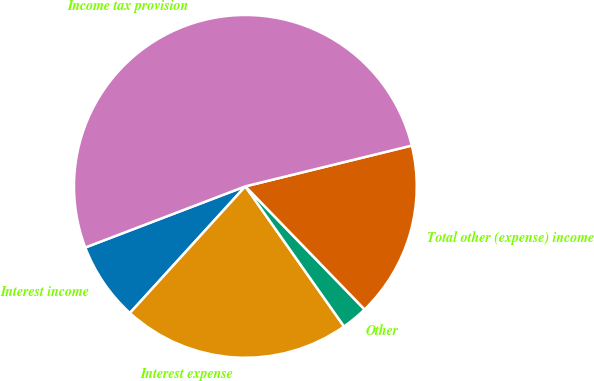Convert chart to OTSL. <chart><loc_0><loc_0><loc_500><loc_500><pie_chart><fcel>Interest income<fcel>Interest expense<fcel>Other<fcel>Total other (expense) income<fcel>Income tax provision<nl><fcel>7.43%<fcel>21.53%<fcel>2.48%<fcel>16.58%<fcel>51.98%<nl></chart> 